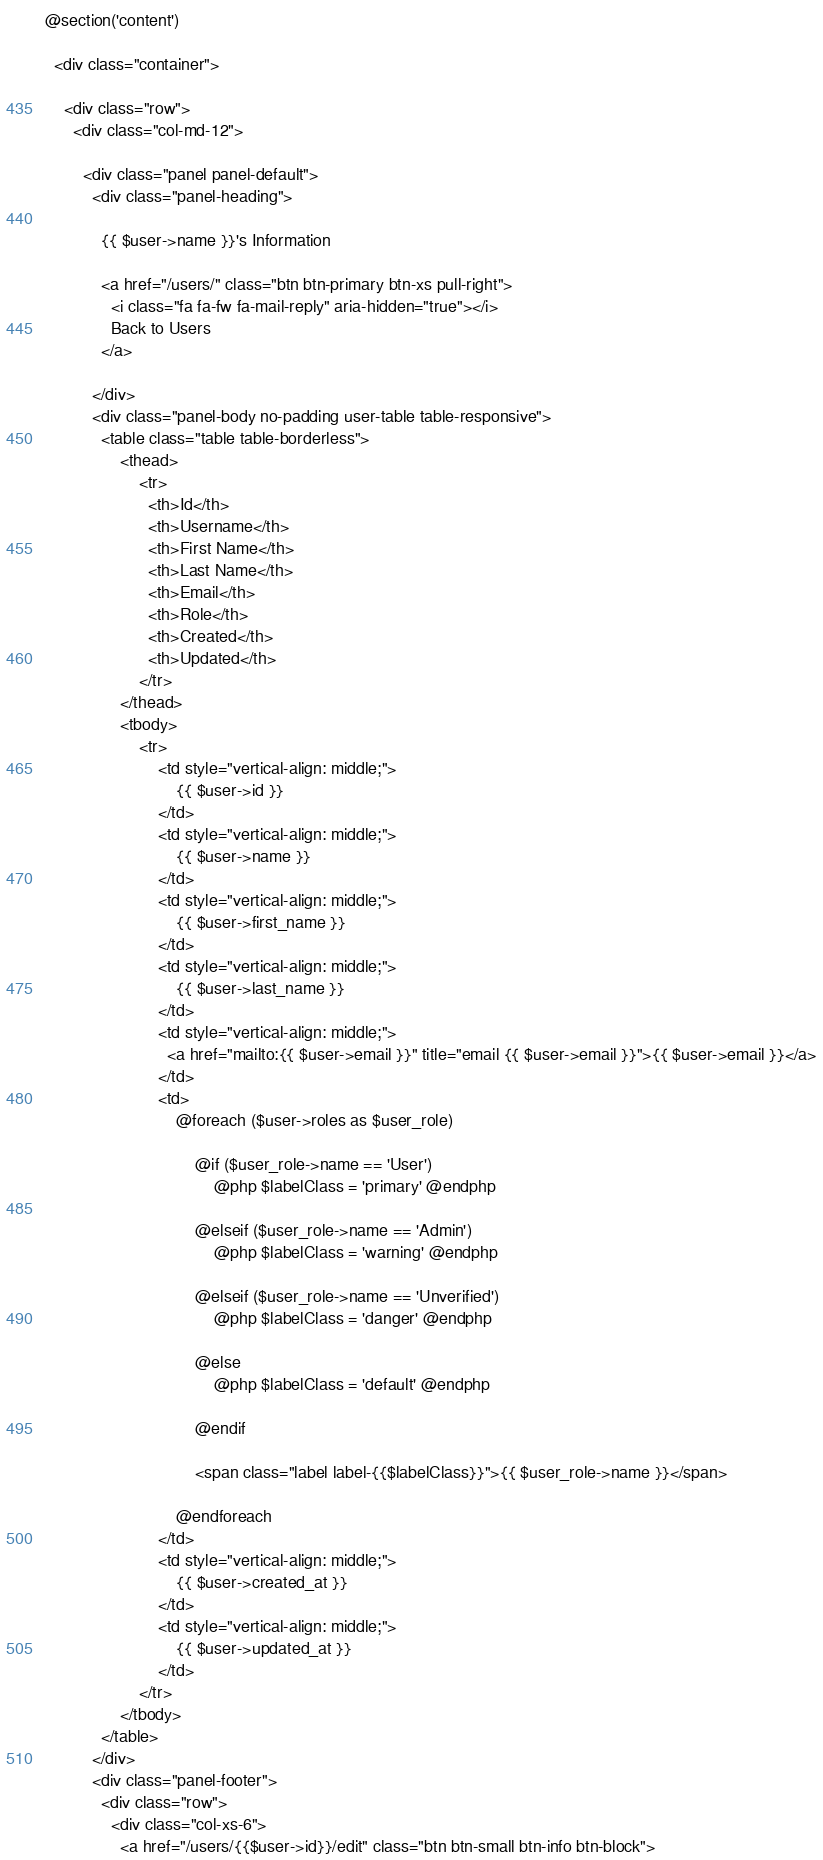Convert code to text. <code><loc_0><loc_0><loc_500><loc_500><_PHP_>
@section('content')

  <div class="container">

    <div class="row">
      <div class="col-md-12">

        <div class="panel panel-default">
          <div class="panel-heading">

            {{ $user->name }}'s Information

            <a href="/users/" class="btn btn-primary btn-xs pull-right">
              <i class="fa fa-fw fa-mail-reply" aria-hidden="true"></i>
              Back to Users
            </a>

          </div>
          <div class="panel-body no-padding user-table table-responsive">
            <table class="table table-borderless">
                <thead>
                    <tr>
                      <th>Id</th>
                      <th>Username</th>
                      <th>First Name</th>
                      <th>Last Name</th>
                      <th>Email</th>
                      <th>Role</th>
                      <th>Created</th>
                      <th>Updated</th>
                    </tr>
                </thead>
                <tbody>
                    <tr>
                        <td style="vertical-align: middle;">
                            {{ $user->id }}
                        </td>
                        <td style="vertical-align: middle;">
                            {{ $user->name }}
                        </td>
                        <td style="vertical-align: middle;">
                            {{ $user->first_name }}
                        </td>
                        <td style="vertical-align: middle;">
                            {{ $user->last_name }}
                        </td>
                        <td style="vertical-align: middle;">
                          <a href="mailto:{{ $user->email }}" title="email {{ $user->email }}">{{ $user->email }}</a>
                        </td>
                        <td>
                            @foreach ($user->roles as $user_role)

                                @if ($user_role->name == 'User')
                                    @php $labelClass = 'primary' @endphp

                                @elseif ($user_role->name == 'Admin')
                                    @php $labelClass = 'warning' @endphp

                                @elseif ($user_role->name == 'Unverified')
                                    @php $labelClass = 'danger' @endphp

                                @else
                                    @php $labelClass = 'default' @endphp

                                @endif

                                <span class="label label-{{$labelClass}}">{{ $user_role->name }}</span>

                            @endforeach
                        </td>
                        <td style="vertical-align: middle;">
                            {{ $user->created_at }}
                        </td>
                        <td style="vertical-align: middle;">
                            {{ $user->updated_at }}
                        </td>
                    </tr>
                </tbody>
            </table>
          </div>
          <div class="panel-footer">
            <div class="row">
              <div class="col-xs-6">
                <a href="/users/{{$user->id}}/edit" class="btn btn-small btn-info btn-block"></code> 